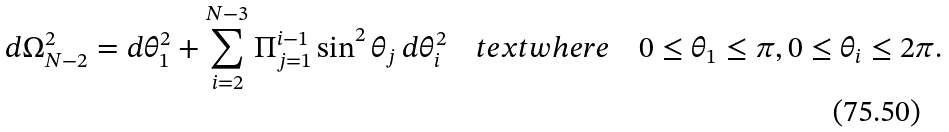Convert formula to latex. <formula><loc_0><loc_0><loc_500><loc_500>d \Omega _ { N - 2 } ^ { 2 } = d \theta _ { 1 } ^ { 2 } + \sum _ { i = 2 } ^ { N - 3 } \Pi _ { j = 1 } ^ { i - 1 } \sin ^ { 2 } \theta _ { j } \, d \theta _ { i } ^ { 2 } \quad t e x t { w h e r e } \quad 0 \leq \theta _ { 1 } \leq \pi , 0 \leq \theta _ { i } \leq 2 \pi .</formula> 